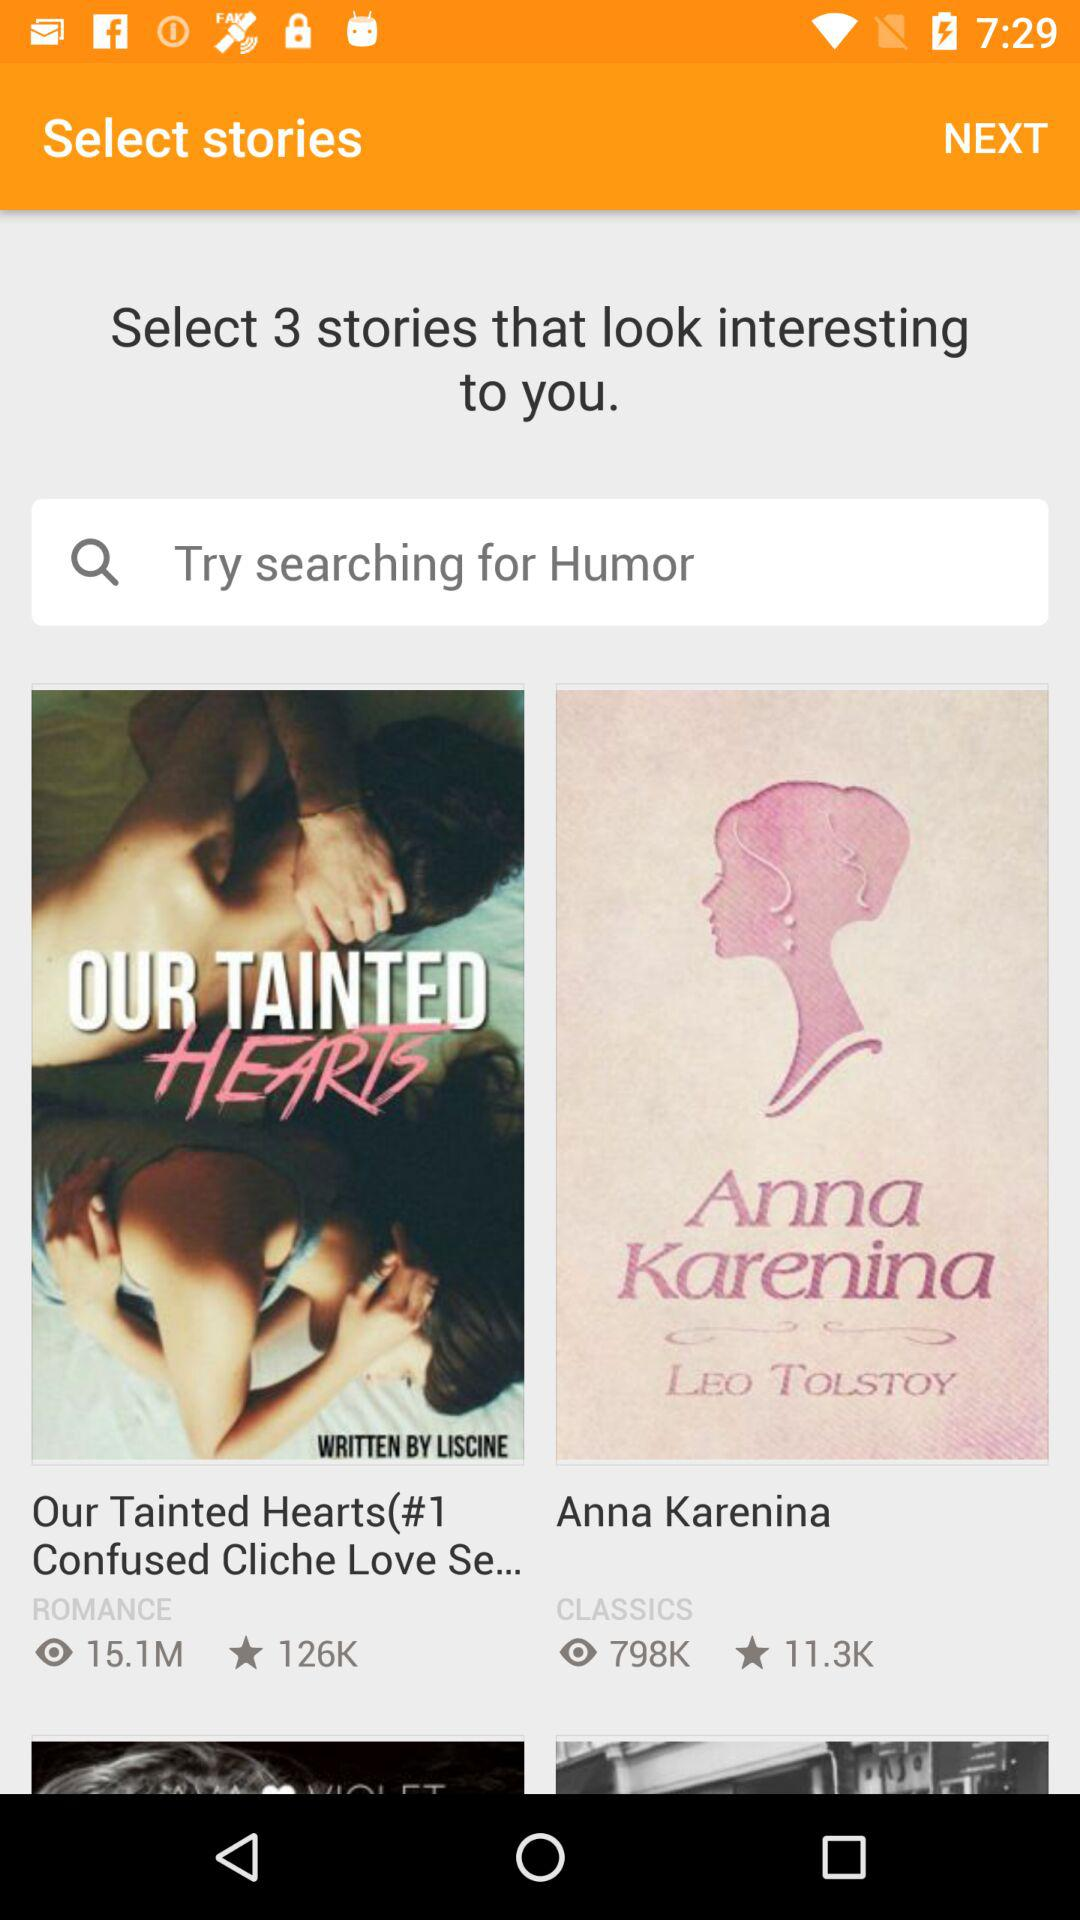What type of story is Anna Karenina? Anna Karenina is "CLASSICS" type of the story. 